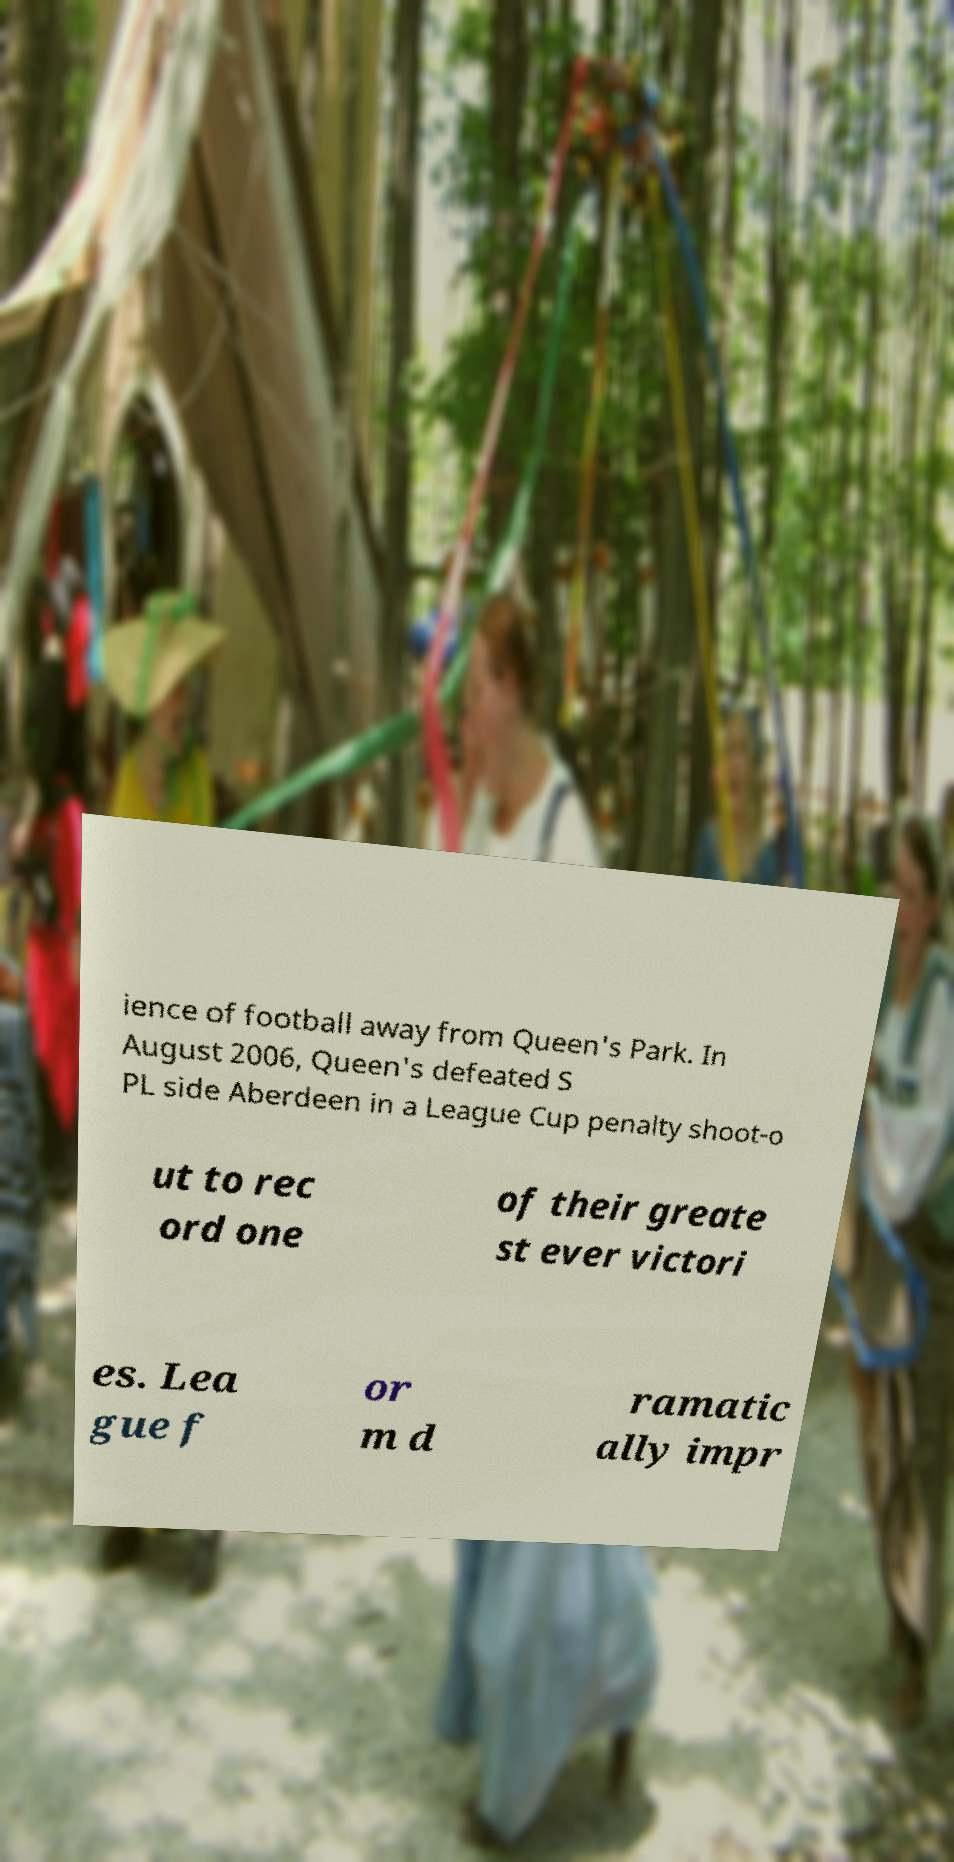I need the written content from this picture converted into text. Can you do that? ience of football away from Queen's Park. In August 2006, Queen's defeated S PL side Aberdeen in a League Cup penalty shoot-o ut to rec ord one of their greate st ever victori es. Lea gue f or m d ramatic ally impr 